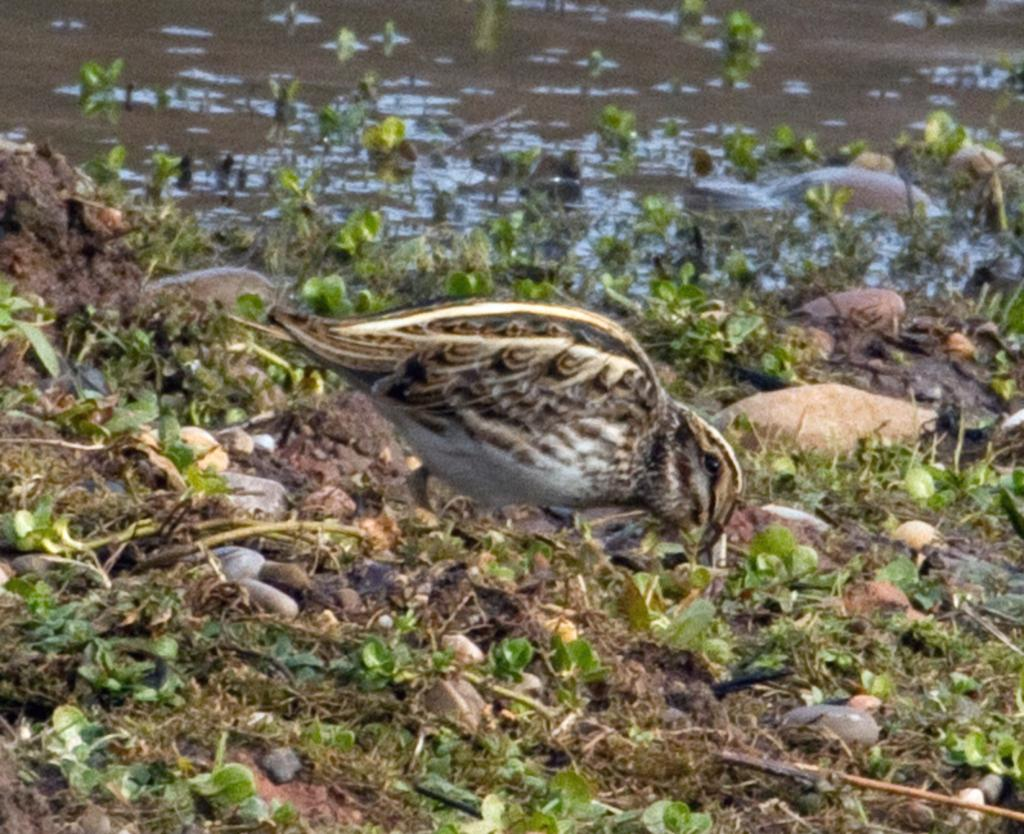What is the main subject in the center of the image? There is a bird in the center of the image. Where is the bird located? The bird is on the grassland. What other objects can be seen in the image? There are pebbles visible in the image. What can be seen at the top side of the image? There is water visible at the top side of the image. How many women are holding a vase in the image? There are no women or vases present in the image. 